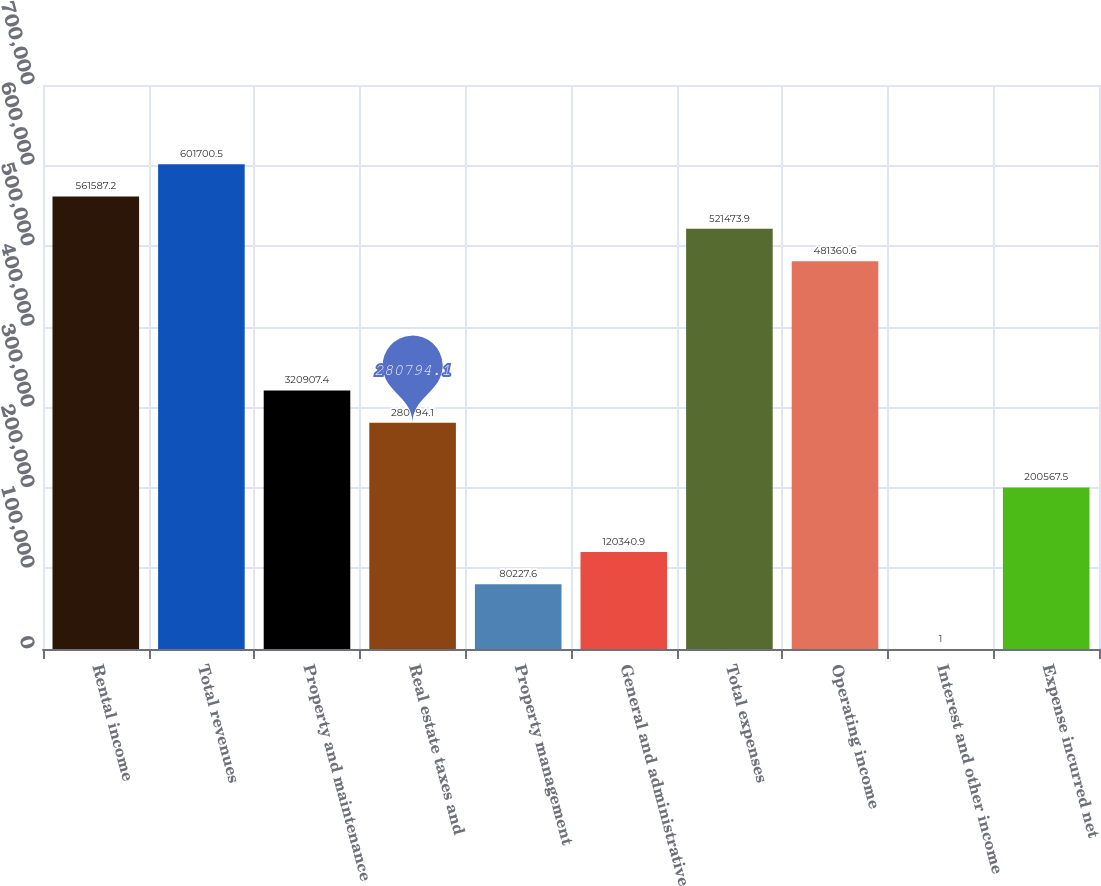<chart> <loc_0><loc_0><loc_500><loc_500><bar_chart><fcel>Rental income<fcel>Total revenues<fcel>Property and maintenance<fcel>Real estate taxes and<fcel>Property management<fcel>General and administrative<fcel>Total expenses<fcel>Operating income<fcel>Interest and other income<fcel>Expense incurred net<nl><fcel>561587<fcel>601700<fcel>320907<fcel>280794<fcel>80227.6<fcel>120341<fcel>521474<fcel>481361<fcel>1<fcel>200568<nl></chart> 